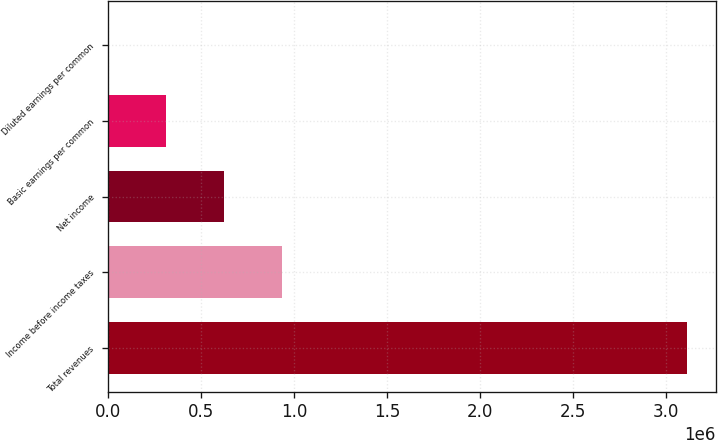Convert chart to OTSL. <chart><loc_0><loc_0><loc_500><loc_500><bar_chart><fcel>Total revenues<fcel>Income before income taxes<fcel>Net income<fcel>Basic earnings per common<fcel>Diluted earnings per common<nl><fcel>3.11176e+06<fcel>933530<fcel>622353<fcel>311177<fcel>0.38<nl></chart> 